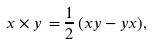<formula> <loc_0><loc_0><loc_500><loc_500>x \times y \, = \, & \frac { 1 } { 2 } \, ( x y - y x ) ,</formula> 